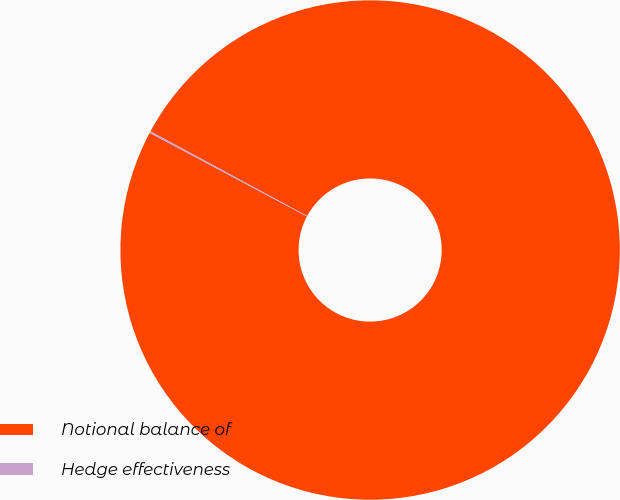Convert chart to OTSL. <chart><loc_0><loc_0><loc_500><loc_500><pie_chart><fcel>Notional balance of<fcel>Hedge effectiveness<nl><fcel>99.89%<fcel>0.11%<nl></chart> 